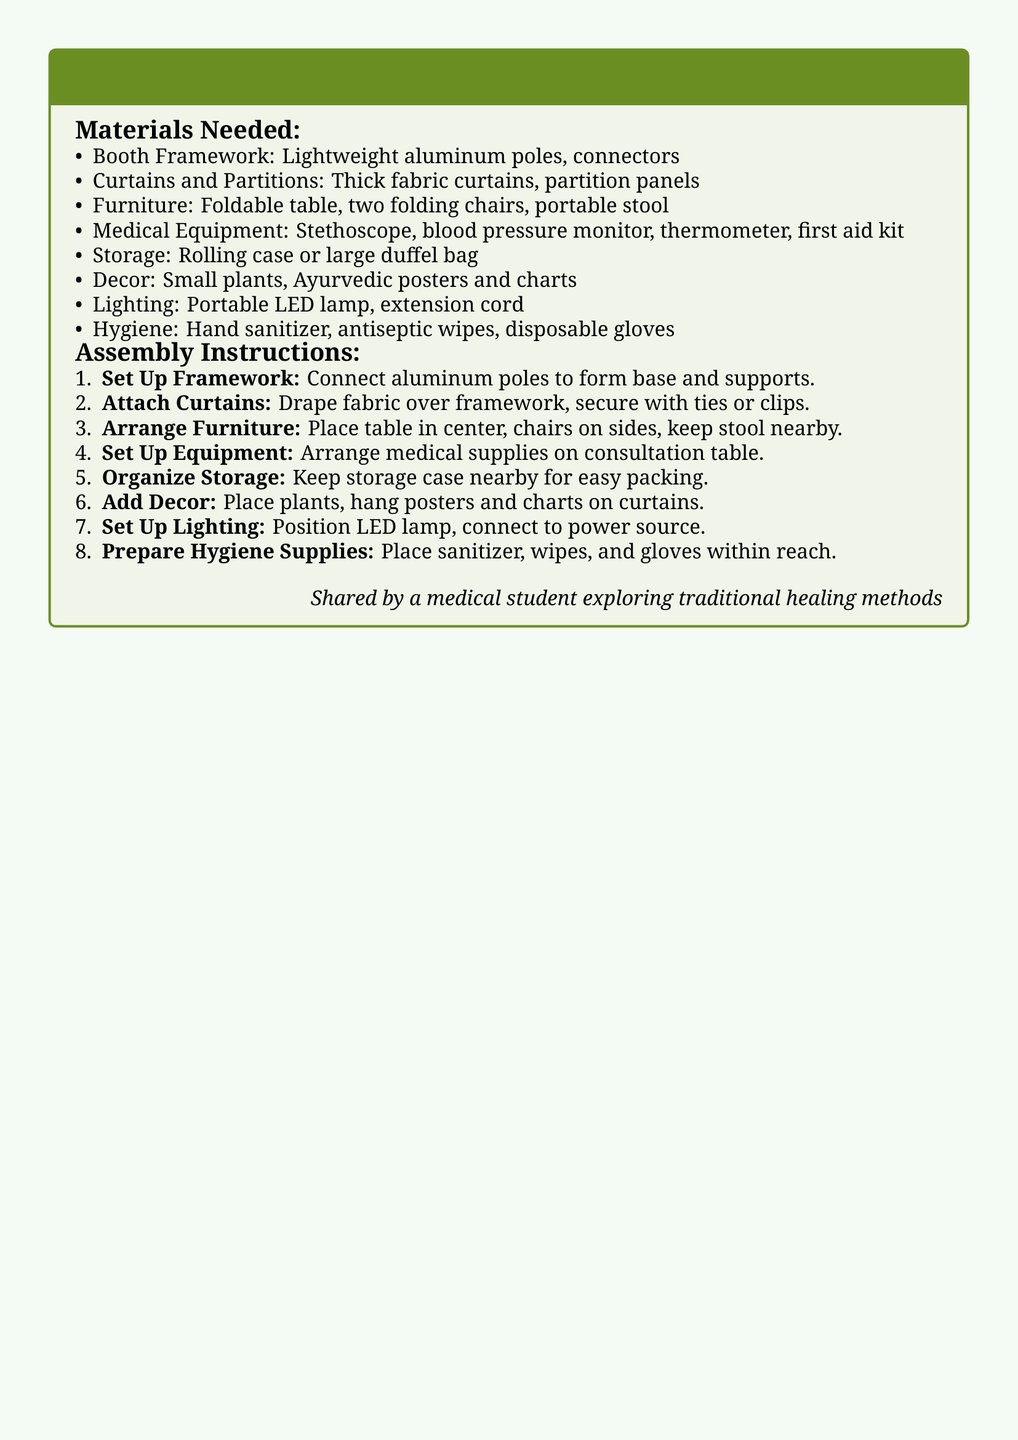What materials are needed for the booth framework? The document lists lightweight aluminum poles and connectors as required materials for the booth framework.
Answer: Lightweight aluminum poles, connectors How many chairs are mentioned in the assembly instructions? The document specifically states that two folding chairs are needed for the assembly.
Answer: Two folding chairs What is the first step in the assembly instructions? The document outlines that the first step is to connect the aluminum poles to form the base and supports of the booth.
Answer: Set Up Framework What type of lighting is recommended for the consultation booth? The assembly instructions specify using a portable LED lamp for lighting.
Answer: Portable LED lamp What hygiene supplies should be prepared? The document mentions hand sanitizer, antiseptic wipes, and disposable gloves as hygiene supplies to be prepared.
Answer: Hand sanitizer, antiseptic wipes, disposable gloves How should the medical equipment be arranged? According to the instructions, the medical supplies should be arranged on the consultation table.
Answer: On consultation table What is the purpose of the storage case mentioned? The document suggests keeping the storage case nearby for easy packing of equipment and materials.
Answer: Easy packing Which decor items are recommended for the booth? The assembly instructions recommend using small plants and Ayurvedic posters and charts as decor items.
Answer: Small plants, Ayurvedic posters and charts What is the last step in the assembly instructions? The final instruction listed involves placing hygiene supplies within reach for easy access during the consultation.
Answer: Prepare Hygiene Supplies 